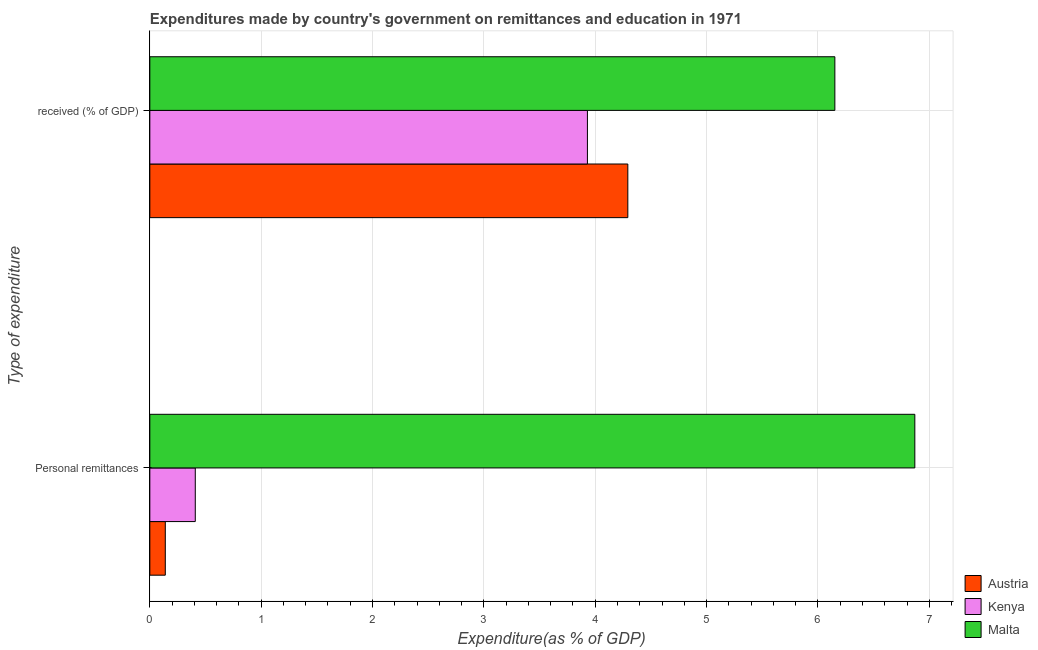How many different coloured bars are there?
Make the answer very short. 3. Are the number of bars per tick equal to the number of legend labels?
Give a very brief answer. Yes. How many bars are there on the 2nd tick from the top?
Provide a succinct answer. 3. What is the label of the 1st group of bars from the top?
Provide a succinct answer.  received (% of GDP). What is the expenditure in education in Kenya?
Provide a short and direct response. 3.93. Across all countries, what is the maximum expenditure in education?
Provide a succinct answer. 6.15. Across all countries, what is the minimum expenditure in education?
Your answer should be compact. 3.93. In which country was the expenditure in personal remittances maximum?
Make the answer very short. Malta. In which country was the expenditure in education minimum?
Make the answer very short. Kenya. What is the total expenditure in education in the graph?
Your answer should be compact. 14.37. What is the difference between the expenditure in personal remittances in Austria and that in Kenya?
Provide a short and direct response. -0.27. What is the difference between the expenditure in personal remittances in Malta and the expenditure in education in Kenya?
Give a very brief answer. 2.94. What is the average expenditure in personal remittances per country?
Offer a terse response. 2.47. What is the difference between the expenditure in education and expenditure in personal remittances in Kenya?
Your answer should be compact. 3.52. In how many countries, is the expenditure in personal remittances greater than 2.6 %?
Keep it short and to the point. 1. What is the ratio of the expenditure in education in Malta to that in Kenya?
Ensure brevity in your answer.  1.57. Is the expenditure in education in Austria less than that in Kenya?
Provide a succinct answer. No. In how many countries, is the expenditure in personal remittances greater than the average expenditure in personal remittances taken over all countries?
Your response must be concise. 1. What does the 1st bar from the top in Personal remittances represents?
Your response must be concise. Malta. What does the 2nd bar from the bottom in  received (% of GDP) represents?
Provide a short and direct response. Kenya. Are all the bars in the graph horizontal?
Ensure brevity in your answer.  Yes. Are the values on the major ticks of X-axis written in scientific E-notation?
Offer a terse response. No. Does the graph contain any zero values?
Make the answer very short. No. Does the graph contain grids?
Make the answer very short. Yes. How many legend labels are there?
Ensure brevity in your answer.  3. What is the title of the graph?
Your answer should be very brief. Expenditures made by country's government on remittances and education in 1971. Does "World" appear as one of the legend labels in the graph?
Provide a short and direct response. No. What is the label or title of the X-axis?
Keep it short and to the point. Expenditure(as % of GDP). What is the label or title of the Y-axis?
Your answer should be compact. Type of expenditure. What is the Expenditure(as % of GDP) of Austria in Personal remittances?
Offer a terse response. 0.14. What is the Expenditure(as % of GDP) in Kenya in Personal remittances?
Make the answer very short. 0.41. What is the Expenditure(as % of GDP) in Malta in Personal remittances?
Provide a succinct answer. 6.87. What is the Expenditure(as % of GDP) of Austria in  received (% of GDP)?
Offer a terse response. 4.29. What is the Expenditure(as % of GDP) in Kenya in  received (% of GDP)?
Offer a terse response. 3.93. What is the Expenditure(as % of GDP) of Malta in  received (% of GDP)?
Provide a short and direct response. 6.15. Across all Type of expenditure, what is the maximum Expenditure(as % of GDP) of Austria?
Provide a short and direct response. 4.29. Across all Type of expenditure, what is the maximum Expenditure(as % of GDP) of Kenya?
Keep it short and to the point. 3.93. Across all Type of expenditure, what is the maximum Expenditure(as % of GDP) in Malta?
Offer a very short reply. 6.87. Across all Type of expenditure, what is the minimum Expenditure(as % of GDP) of Austria?
Provide a succinct answer. 0.14. Across all Type of expenditure, what is the minimum Expenditure(as % of GDP) in Kenya?
Your answer should be compact. 0.41. Across all Type of expenditure, what is the minimum Expenditure(as % of GDP) in Malta?
Your answer should be compact. 6.15. What is the total Expenditure(as % of GDP) of Austria in the graph?
Provide a succinct answer. 4.43. What is the total Expenditure(as % of GDP) of Kenya in the graph?
Ensure brevity in your answer.  4.34. What is the total Expenditure(as % of GDP) of Malta in the graph?
Ensure brevity in your answer.  13.02. What is the difference between the Expenditure(as % of GDP) of Austria in Personal remittances and that in  received (% of GDP)?
Your answer should be compact. -4.15. What is the difference between the Expenditure(as % of GDP) of Kenya in Personal remittances and that in  received (% of GDP)?
Your answer should be compact. -3.52. What is the difference between the Expenditure(as % of GDP) of Malta in Personal remittances and that in  received (% of GDP)?
Provide a short and direct response. 0.72. What is the difference between the Expenditure(as % of GDP) of Austria in Personal remittances and the Expenditure(as % of GDP) of Kenya in  received (% of GDP)?
Make the answer very short. -3.79. What is the difference between the Expenditure(as % of GDP) in Austria in Personal remittances and the Expenditure(as % of GDP) in Malta in  received (% of GDP)?
Your response must be concise. -6.01. What is the difference between the Expenditure(as % of GDP) of Kenya in Personal remittances and the Expenditure(as % of GDP) of Malta in  received (% of GDP)?
Your answer should be very brief. -5.74. What is the average Expenditure(as % of GDP) of Austria per Type of expenditure?
Your answer should be compact. 2.22. What is the average Expenditure(as % of GDP) in Kenya per Type of expenditure?
Offer a terse response. 2.17. What is the average Expenditure(as % of GDP) of Malta per Type of expenditure?
Provide a succinct answer. 6.51. What is the difference between the Expenditure(as % of GDP) in Austria and Expenditure(as % of GDP) in Kenya in Personal remittances?
Your response must be concise. -0.27. What is the difference between the Expenditure(as % of GDP) of Austria and Expenditure(as % of GDP) of Malta in Personal remittances?
Your answer should be compact. -6.73. What is the difference between the Expenditure(as % of GDP) of Kenya and Expenditure(as % of GDP) of Malta in Personal remittances?
Ensure brevity in your answer.  -6.46. What is the difference between the Expenditure(as % of GDP) of Austria and Expenditure(as % of GDP) of Kenya in  received (% of GDP)?
Your response must be concise. 0.36. What is the difference between the Expenditure(as % of GDP) in Austria and Expenditure(as % of GDP) in Malta in  received (% of GDP)?
Offer a terse response. -1.86. What is the difference between the Expenditure(as % of GDP) of Kenya and Expenditure(as % of GDP) of Malta in  received (% of GDP)?
Keep it short and to the point. -2.22. What is the ratio of the Expenditure(as % of GDP) in Austria in Personal remittances to that in  received (% of GDP)?
Keep it short and to the point. 0.03. What is the ratio of the Expenditure(as % of GDP) in Kenya in Personal remittances to that in  received (% of GDP)?
Your answer should be compact. 0.1. What is the ratio of the Expenditure(as % of GDP) of Malta in Personal remittances to that in  received (% of GDP)?
Provide a short and direct response. 1.12. What is the difference between the highest and the second highest Expenditure(as % of GDP) of Austria?
Ensure brevity in your answer.  4.15. What is the difference between the highest and the second highest Expenditure(as % of GDP) in Kenya?
Your response must be concise. 3.52. What is the difference between the highest and the second highest Expenditure(as % of GDP) of Malta?
Make the answer very short. 0.72. What is the difference between the highest and the lowest Expenditure(as % of GDP) of Austria?
Give a very brief answer. 4.15. What is the difference between the highest and the lowest Expenditure(as % of GDP) of Kenya?
Ensure brevity in your answer.  3.52. What is the difference between the highest and the lowest Expenditure(as % of GDP) of Malta?
Keep it short and to the point. 0.72. 